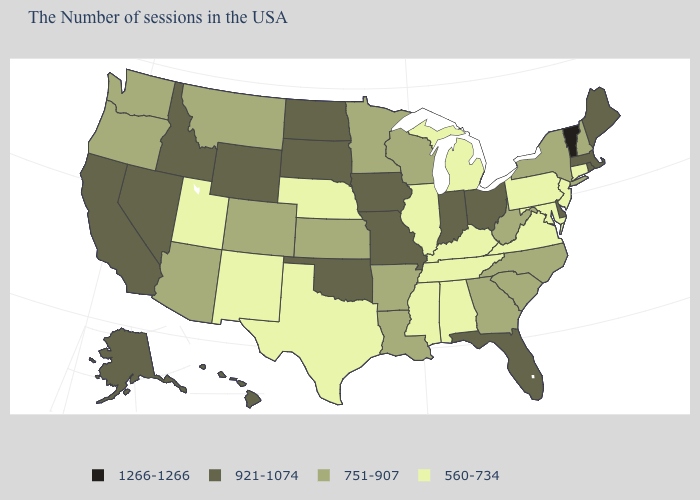Name the states that have a value in the range 921-1074?
Keep it brief. Maine, Massachusetts, Rhode Island, Delaware, Ohio, Florida, Indiana, Missouri, Iowa, Oklahoma, South Dakota, North Dakota, Wyoming, Idaho, Nevada, California, Alaska, Hawaii. Name the states that have a value in the range 921-1074?
Write a very short answer. Maine, Massachusetts, Rhode Island, Delaware, Ohio, Florida, Indiana, Missouri, Iowa, Oklahoma, South Dakota, North Dakota, Wyoming, Idaho, Nevada, California, Alaska, Hawaii. What is the value of Idaho?
Write a very short answer. 921-1074. What is the value of Kentucky?
Concise answer only. 560-734. Does South Dakota have the lowest value in the MidWest?
Keep it brief. No. Does Alaska have the highest value in the West?
Write a very short answer. Yes. Which states have the lowest value in the USA?
Write a very short answer. Connecticut, New Jersey, Maryland, Pennsylvania, Virginia, Michigan, Kentucky, Alabama, Tennessee, Illinois, Mississippi, Nebraska, Texas, New Mexico, Utah. What is the lowest value in states that border Michigan?
Be succinct. 751-907. Which states have the lowest value in the USA?
Give a very brief answer. Connecticut, New Jersey, Maryland, Pennsylvania, Virginia, Michigan, Kentucky, Alabama, Tennessee, Illinois, Mississippi, Nebraska, Texas, New Mexico, Utah. Name the states that have a value in the range 751-907?
Quick response, please. New Hampshire, New York, North Carolina, South Carolina, West Virginia, Georgia, Wisconsin, Louisiana, Arkansas, Minnesota, Kansas, Colorado, Montana, Arizona, Washington, Oregon. Among the states that border Ohio , does West Virginia have the lowest value?
Write a very short answer. No. Name the states that have a value in the range 751-907?
Concise answer only. New Hampshire, New York, North Carolina, South Carolina, West Virginia, Georgia, Wisconsin, Louisiana, Arkansas, Minnesota, Kansas, Colorado, Montana, Arizona, Washington, Oregon. Does the first symbol in the legend represent the smallest category?
Keep it brief. No. What is the value of Pennsylvania?
Be succinct. 560-734. Name the states that have a value in the range 921-1074?
Give a very brief answer. Maine, Massachusetts, Rhode Island, Delaware, Ohio, Florida, Indiana, Missouri, Iowa, Oklahoma, South Dakota, North Dakota, Wyoming, Idaho, Nevada, California, Alaska, Hawaii. 